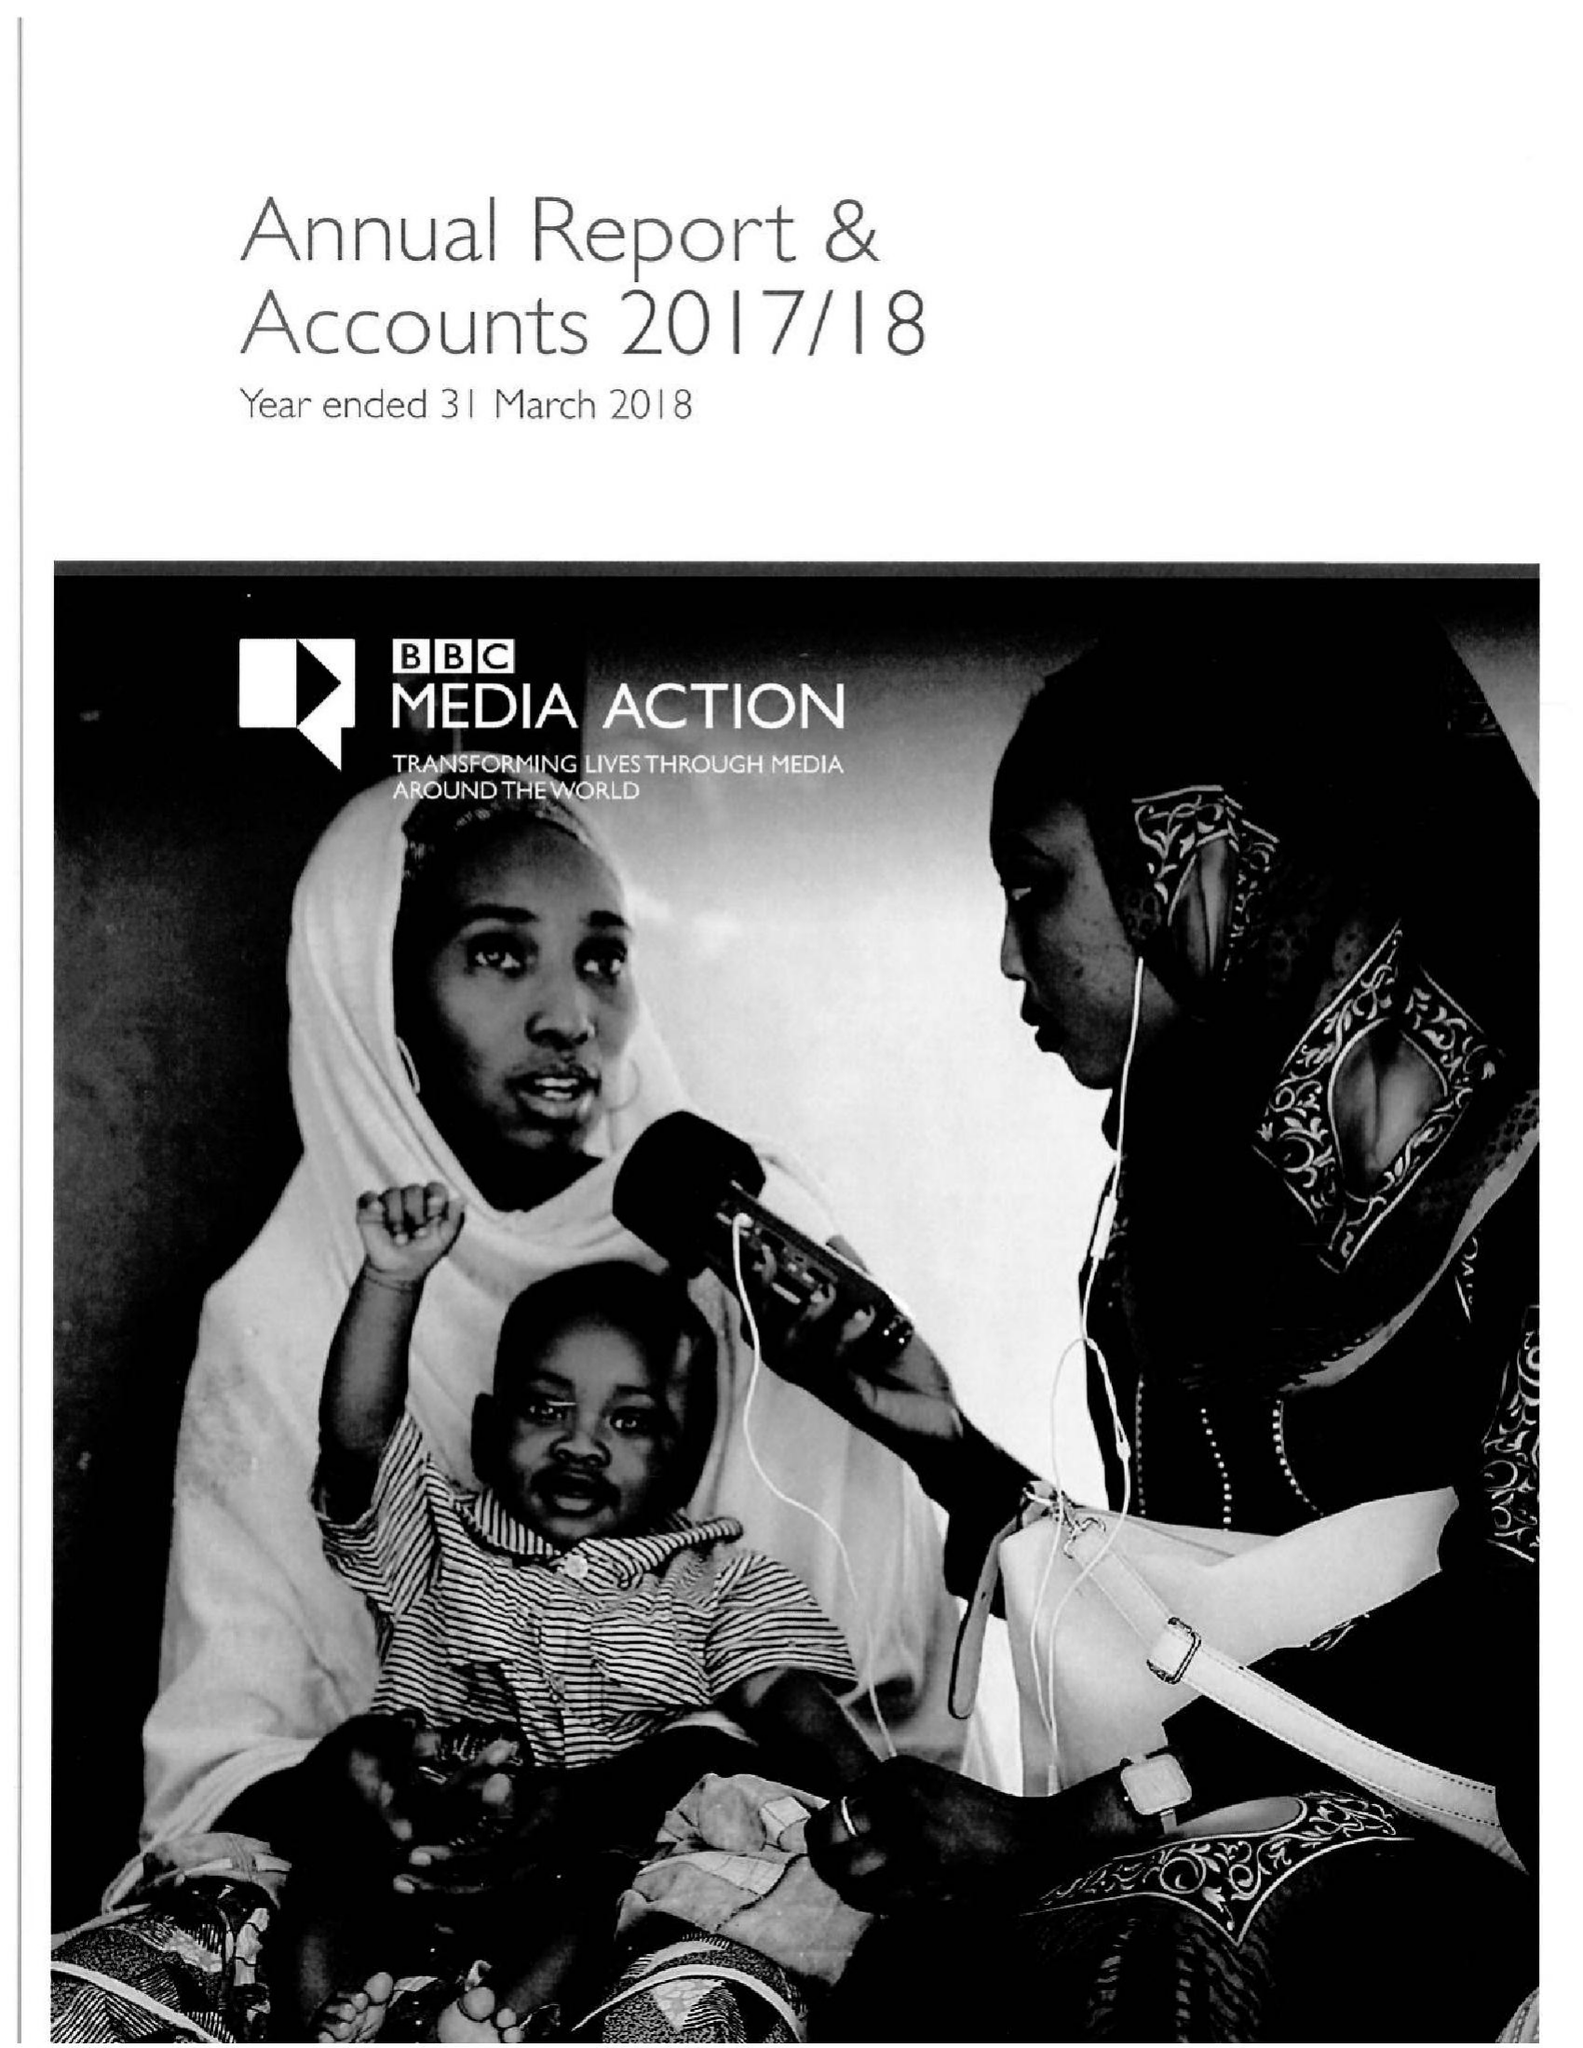What is the value for the income_annually_in_british_pounds?
Answer the question using a single word or phrase. 35389699.00 